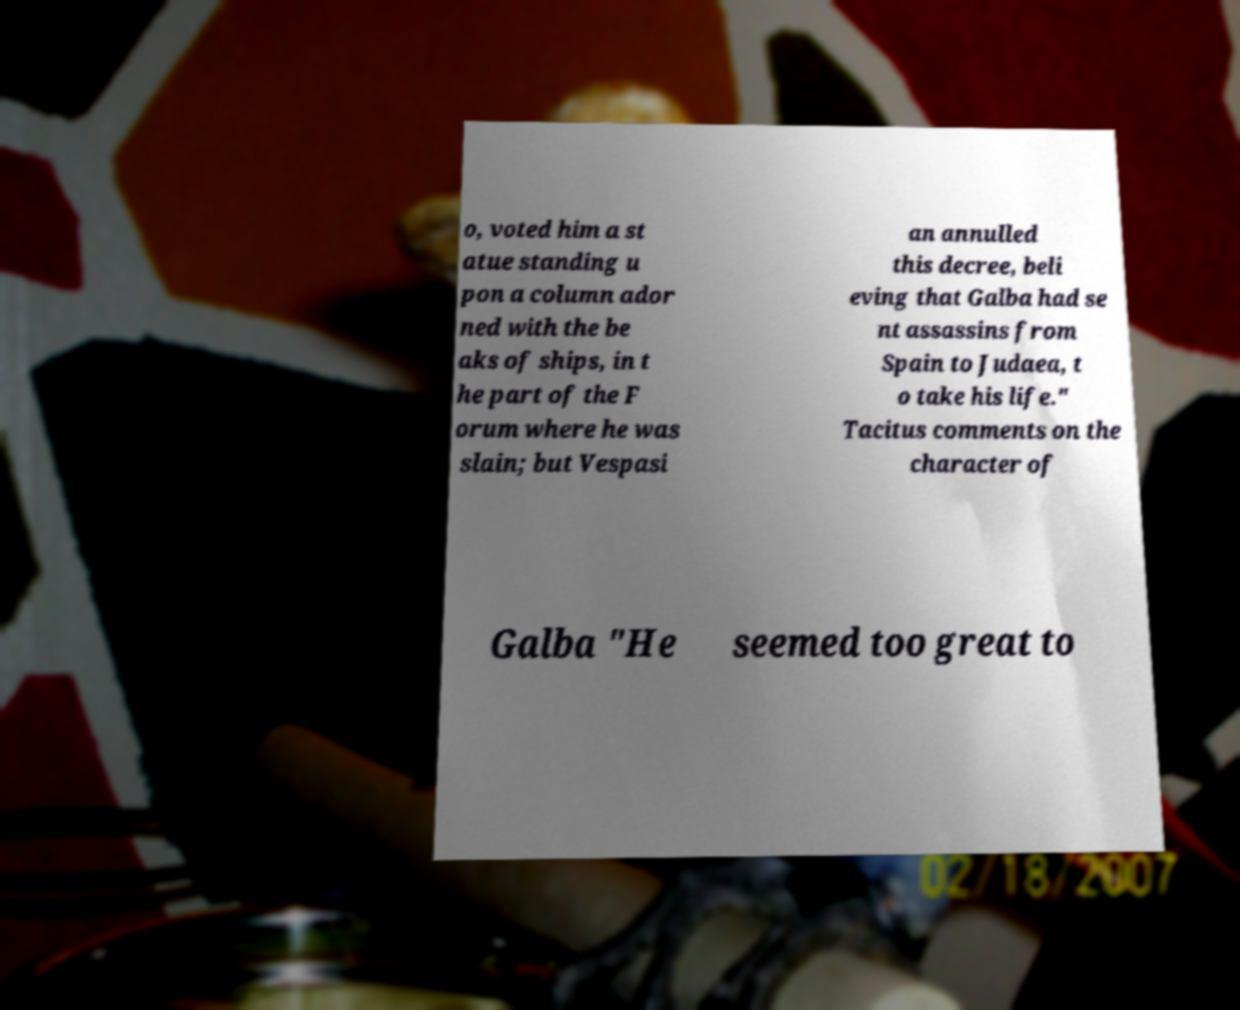Could you assist in decoding the text presented in this image and type it out clearly? o, voted him a st atue standing u pon a column ador ned with the be aks of ships, in t he part of the F orum where he was slain; but Vespasi an annulled this decree, beli eving that Galba had se nt assassins from Spain to Judaea, t o take his life." Tacitus comments on the character of Galba "He seemed too great to 